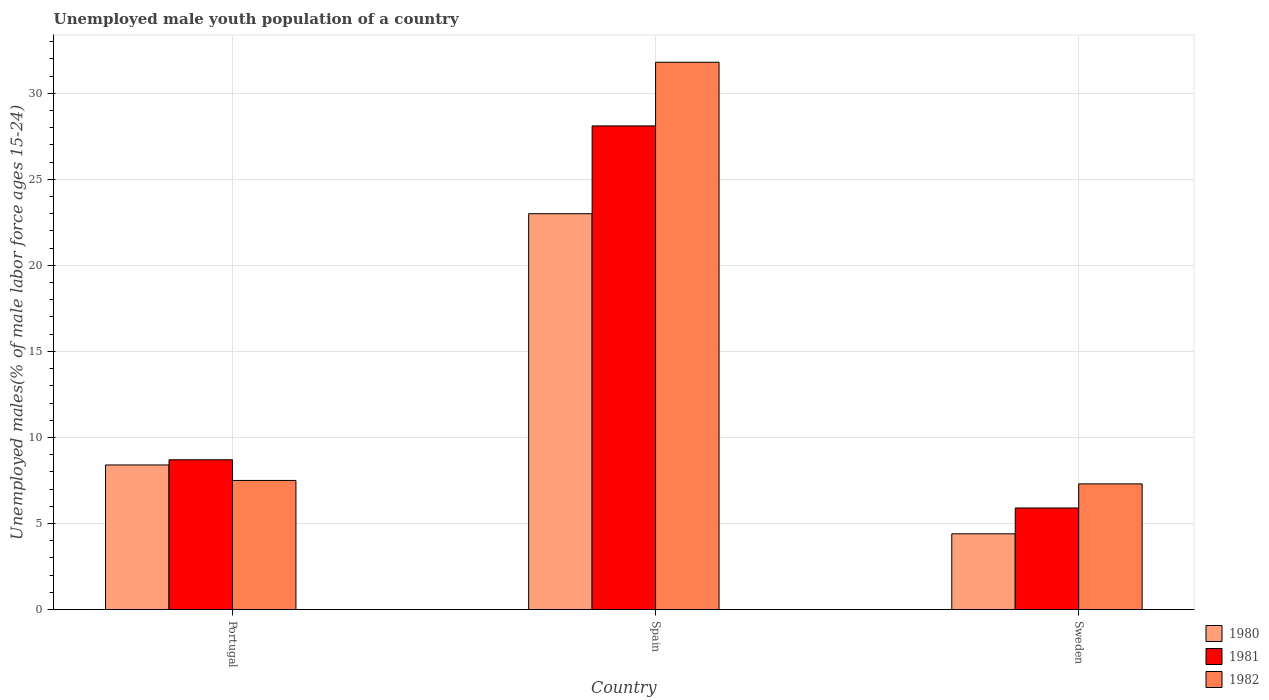Across all countries, what is the maximum percentage of unemployed male youth population in 1982?
Provide a succinct answer. 31.8. Across all countries, what is the minimum percentage of unemployed male youth population in 1981?
Make the answer very short. 5.9. In which country was the percentage of unemployed male youth population in 1980 maximum?
Give a very brief answer. Spain. What is the total percentage of unemployed male youth population in 1982 in the graph?
Offer a very short reply. 46.6. What is the difference between the percentage of unemployed male youth population in 1980 in Portugal and that in Sweden?
Your answer should be very brief. 4. What is the difference between the percentage of unemployed male youth population in 1981 in Sweden and the percentage of unemployed male youth population in 1982 in Spain?
Offer a very short reply. -25.9. What is the average percentage of unemployed male youth population in 1982 per country?
Give a very brief answer. 15.53. What is the difference between the percentage of unemployed male youth population of/in 1982 and percentage of unemployed male youth population of/in 1981 in Portugal?
Your answer should be very brief. -1.2. In how many countries, is the percentage of unemployed male youth population in 1980 greater than 4 %?
Ensure brevity in your answer.  3. What is the ratio of the percentage of unemployed male youth population in 1982 in Spain to that in Sweden?
Offer a terse response. 4.36. What is the difference between the highest and the second highest percentage of unemployed male youth population in 1982?
Offer a very short reply. -0.2. What is the difference between the highest and the lowest percentage of unemployed male youth population in 1980?
Your answer should be very brief. 18.6. Is the sum of the percentage of unemployed male youth population in 1982 in Spain and Sweden greater than the maximum percentage of unemployed male youth population in 1980 across all countries?
Offer a terse response. Yes. What does the 3rd bar from the left in Spain represents?
Make the answer very short. 1982. How many bars are there?
Make the answer very short. 9. How many countries are there in the graph?
Your response must be concise. 3. What is the difference between two consecutive major ticks on the Y-axis?
Keep it short and to the point. 5. Does the graph contain any zero values?
Offer a terse response. No. How many legend labels are there?
Make the answer very short. 3. How are the legend labels stacked?
Provide a succinct answer. Vertical. What is the title of the graph?
Offer a very short reply. Unemployed male youth population of a country. What is the label or title of the Y-axis?
Your answer should be very brief. Unemployed males(% of male labor force ages 15-24). What is the Unemployed males(% of male labor force ages 15-24) in 1980 in Portugal?
Provide a succinct answer. 8.4. What is the Unemployed males(% of male labor force ages 15-24) of 1981 in Portugal?
Make the answer very short. 8.7. What is the Unemployed males(% of male labor force ages 15-24) in 1982 in Portugal?
Offer a very short reply. 7.5. What is the Unemployed males(% of male labor force ages 15-24) in 1980 in Spain?
Your answer should be compact. 23. What is the Unemployed males(% of male labor force ages 15-24) of 1981 in Spain?
Your answer should be compact. 28.1. What is the Unemployed males(% of male labor force ages 15-24) in 1982 in Spain?
Give a very brief answer. 31.8. What is the Unemployed males(% of male labor force ages 15-24) of 1980 in Sweden?
Provide a short and direct response. 4.4. What is the Unemployed males(% of male labor force ages 15-24) of 1981 in Sweden?
Keep it short and to the point. 5.9. What is the Unemployed males(% of male labor force ages 15-24) of 1982 in Sweden?
Offer a very short reply. 7.3. Across all countries, what is the maximum Unemployed males(% of male labor force ages 15-24) in 1980?
Your response must be concise. 23. Across all countries, what is the maximum Unemployed males(% of male labor force ages 15-24) of 1981?
Provide a succinct answer. 28.1. Across all countries, what is the maximum Unemployed males(% of male labor force ages 15-24) of 1982?
Offer a very short reply. 31.8. Across all countries, what is the minimum Unemployed males(% of male labor force ages 15-24) of 1980?
Offer a terse response. 4.4. Across all countries, what is the minimum Unemployed males(% of male labor force ages 15-24) of 1981?
Offer a terse response. 5.9. Across all countries, what is the minimum Unemployed males(% of male labor force ages 15-24) in 1982?
Provide a succinct answer. 7.3. What is the total Unemployed males(% of male labor force ages 15-24) of 1980 in the graph?
Provide a short and direct response. 35.8. What is the total Unemployed males(% of male labor force ages 15-24) in 1981 in the graph?
Your answer should be compact. 42.7. What is the total Unemployed males(% of male labor force ages 15-24) of 1982 in the graph?
Make the answer very short. 46.6. What is the difference between the Unemployed males(% of male labor force ages 15-24) of 1980 in Portugal and that in Spain?
Offer a terse response. -14.6. What is the difference between the Unemployed males(% of male labor force ages 15-24) in 1981 in Portugal and that in Spain?
Keep it short and to the point. -19.4. What is the difference between the Unemployed males(% of male labor force ages 15-24) of 1982 in Portugal and that in Spain?
Provide a succinct answer. -24.3. What is the difference between the Unemployed males(% of male labor force ages 15-24) in 1980 in Portugal and that in Sweden?
Give a very brief answer. 4. What is the difference between the Unemployed males(% of male labor force ages 15-24) in 1980 in Spain and that in Sweden?
Provide a succinct answer. 18.6. What is the difference between the Unemployed males(% of male labor force ages 15-24) of 1980 in Portugal and the Unemployed males(% of male labor force ages 15-24) of 1981 in Spain?
Provide a short and direct response. -19.7. What is the difference between the Unemployed males(% of male labor force ages 15-24) in 1980 in Portugal and the Unemployed males(% of male labor force ages 15-24) in 1982 in Spain?
Your answer should be very brief. -23.4. What is the difference between the Unemployed males(% of male labor force ages 15-24) of 1981 in Portugal and the Unemployed males(% of male labor force ages 15-24) of 1982 in Spain?
Make the answer very short. -23.1. What is the difference between the Unemployed males(% of male labor force ages 15-24) of 1980 in Portugal and the Unemployed males(% of male labor force ages 15-24) of 1981 in Sweden?
Your response must be concise. 2.5. What is the difference between the Unemployed males(% of male labor force ages 15-24) of 1981 in Spain and the Unemployed males(% of male labor force ages 15-24) of 1982 in Sweden?
Your answer should be very brief. 20.8. What is the average Unemployed males(% of male labor force ages 15-24) of 1980 per country?
Make the answer very short. 11.93. What is the average Unemployed males(% of male labor force ages 15-24) in 1981 per country?
Ensure brevity in your answer.  14.23. What is the average Unemployed males(% of male labor force ages 15-24) of 1982 per country?
Ensure brevity in your answer.  15.53. What is the difference between the Unemployed males(% of male labor force ages 15-24) in 1980 and Unemployed males(% of male labor force ages 15-24) in 1982 in Portugal?
Ensure brevity in your answer.  0.9. What is the difference between the Unemployed males(% of male labor force ages 15-24) in 1981 and Unemployed males(% of male labor force ages 15-24) in 1982 in Portugal?
Offer a terse response. 1.2. What is the difference between the Unemployed males(% of male labor force ages 15-24) of 1980 and Unemployed males(% of male labor force ages 15-24) of 1981 in Spain?
Your answer should be very brief. -5.1. What is the difference between the Unemployed males(% of male labor force ages 15-24) of 1980 and Unemployed males(% of male labor force ages 15-24) of 1982 in Spain?
Make the answer very short. -8.8. What is the difference between the Unemployed males(% of male labor force ages 15-24) in 1981 and Unemployed males(% of male labor force ages 15-24) in 1982 in Spain?
Offer a terse response. -3.7. What is the difference between the Unemployed males(% of male labor force ages 15-24) of 1980 and Unemployed males(% of male labor force ages 15-24) of 1982 in Sweden?
Give a very brief answer. -2.9. What is the difference between the Unemployed males(% of male labor force ages 15-24) of 1981 and Unemployed males(% of male labor force ages 15-24) of 1982 in Sweden?
Offer a terse response. -1.4. What is the ratio of the Unemployed males(% of male labor force ages 15-24) in 1980 in Portugal to that in Spain?
Your answer should be compact. 0.37. What is the ratio of the Unemployed males(% of male labor force ages 15-24) of 1981 in Portugal to that in Spain?
Your answer should be compact. 0.31. What is the ratio of the Unemployed males(% of male labor force ages 15-24) of 1982 in Portugal to that in Spain?
Your answer should be compact. 0.24. What is the ratio of the Unemployed males(% of male labor force ages 15-24) of 1980 in Portugal to that in Sweden?
Your answer should be very brief. 1.91. What is the ratio of the Unemployed males(% of male labor force ages 15-24) of 1981 in Portugal to that in Sweden?
Give a very brief answer. 1.47. What is the ratio of the Unemployed males(% of male labor force ages 15-24) in 1982 in Portugal to that in Sweden?
Make the answer very short. 1.03. What is the ratio of the Unemployed males(% of male labor force ages 15-24) of 1980 in Spain to that in Sweden?
Your answer should be very brief. 5.23. What is the ratio of the Unemployed males(% of male labor force ages 15-24) of 1981 in Spain to that in Sweden?
Provide a succinct answer. 4.76. What is the ratio of the Unemployed males(% of male labor force ages 15-24) in 1982 in Spain to that in Sweden?
Ensure brevity in your answer.  4.36. What is the difference between the highest and the second highest Unemployed males(% of male labor force ages 15-24) in 1980?
Ensure brevity in your answer.  14.6. What is the difference between the highest and the second highest Unemployed males(% of male labor force ages 15-24) in 1982?
Your response must be concise. 24.3. What is the difference between the highest and the lowest Unemployed males(% of male labor force ages 15-24) of 1982?
Your answer should be compact. 24.5. 